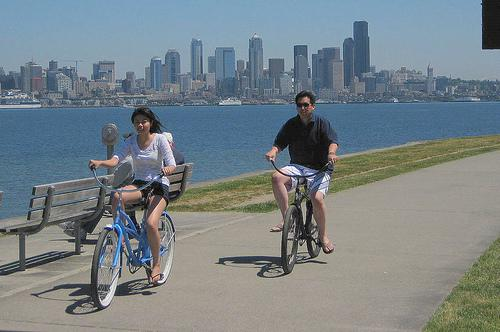Question: what are the people doing?
Choices:
A. Running.
B. Jumping.
C. Riding.
D. Laughing.
Answer with the letter. Answer: C Question: how many people are there?
Choices:
A. One.
B. Two.
C. Four.
D. Five.
Answer with the letter. Answer: B Question: where are the people?
Choices:
A. Sidewalk.
B. Street.
C. Field.
D. Road.
Answer with the letter. Answer: A 